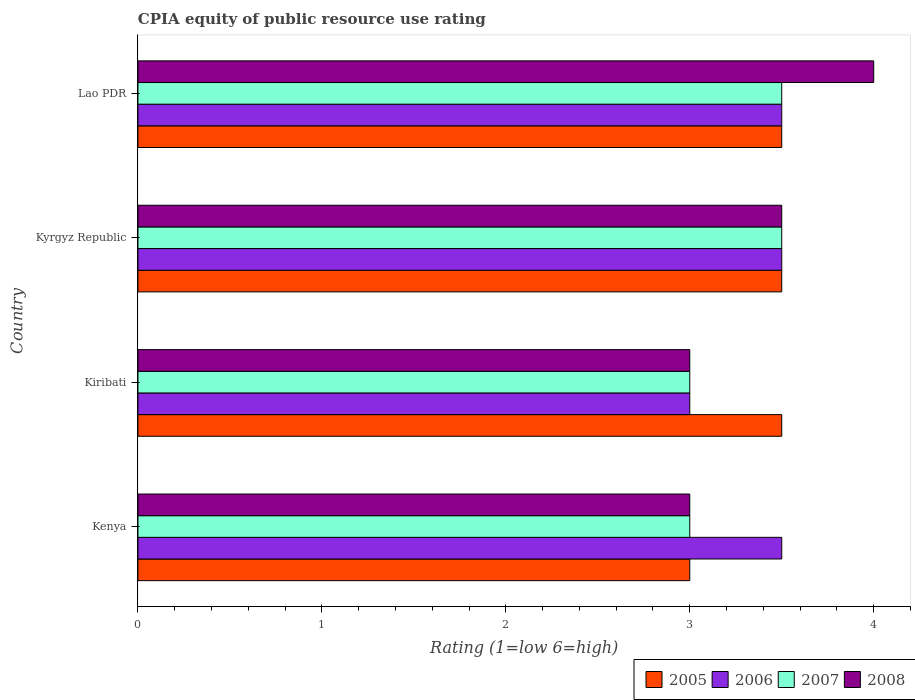Are the number of bars per tick equal to the number of legend labels?
Your answer should be very brief. Yes. Are the number of bars on each tick of the Y-axis equal?
Your answer should be compact. Yes. What is the label of the 2nd group of bars from the top?
Make the answer very short. Kyrgyz Republic. Across all countries, what is the maximum CPIA rating in 2006?
Your answer should be compact. 3.5. In which country was the CPIA rating in 2007 maximum?
Offer a very short reply. Kyrgyz Republic. In which country was the CPIA rating in 2006 minimum?
Offer a very short reply. Kiribati. What is the total CPIA rating in 2005 in the graph?
Keep it short and to the point. 13.5. What is the difference between the CPIA rating in 2005 in Lao PDR and the CPIA rating in 2007 in Kiribati?
Offer a terse response. 0.5. What is the average CPIA rating in 2008 per country?
Your answer should be very brief. 3.38. In how many countries, is the CPIA rating in 2005 greater than 0.8 ?
Offer a very short reply. 4. What is the ratio of the CPIA rating in 2005 in Kenya to that in Kiribati?
Your answer should be compact. 0.86. Is the CPIA rating in 2007 in Kiribati less than that in Lao PDR?
Make the answer very short. Yes. Is the difference between the CPIA rating in 2008 in Kenya and Kiribati greater than the difference between the CPIA rating in 2007 in Kenya and Kiribati?
Make the answer very short. No. What is the difference between the highest and the lowest CPIA rating in 2007?
Keep it short and to the point. 0.5. In how many countries, is the CPIA rating in 2006 greater than the average CPIA rating in 2006 taken over all countries?
Give a very brief answer. 3. What does the 2nd bar from the bottom in Kyrgyz Republic represents?
Your answer should be very brief. 2006. How many bars are there?
Give a very brief answer. 16. How many countries are there in the graph?
Give a very brief answer. 4. What is the difference between two consecutive major ticks on the X-axis?
Ensure brevity in your answer.  1. Are the values on the major ticks of X-axis written in scientific E-notation?
Ensure brevity in your answer.  No. Does the graph contain any zero values?
Ensure brevity in your answer.  No. Does the graph contain grids?
Keep it short and to the point. No. How many legend labels are there?
Provide a succinct answer. 4. What is the title of the graph?
Ensure brevity in your answer.  CPIA equity of public resource use rating. What is the label or title of the X-axis?
Offer a very short reply. Rating (1=low 6=high). What is the label or title of the Y-axis?
Your answer should be very brief. Country. What is the Rating (1=low 6=high) of 2008 in Kenya?
Your answer should be compact. 3. What is the Rating (1=low 6=high) in 2006 in Kyrgyz Republic?
Your response must be concise. 3.5. What is the Rating (1=low 6=high) of 2007 in Kyrgyz Republic?
Keep it short and to the point. 3.5. What is the Rating (1=low 6=high) in 2005 in Lao PDR?
Your answer should be very brief. 3.5. What is the Rating (1=low 6=high) in 2006 in Lao PDR?
Provide a short and direct response. 3.5. What is the Rating (1=low 6=high) in 2007 in Lao PDR?
Keep it short and to the point. 3.5. What is the Rating (1=low 6=high) in 2008 in Lao PDR?
Offer a terse response. 4. Across all countries, what is the maximum Rating (1=low 6=high) of 2005?
Offer a very short reply. 3.5. Across all countries, what is the maximum Rating (1=low 6=high) of 2007?
Your response must be concise. 3.5. Across all countries, what is the minimum Rating (1=low 6=high) in 2005?
Offer a very short reply. 3. Across all countries, what is the minimum Rating (1=low 6=high) in 2008?
Make the answer very short. 3. What is the total Rating (1=low 6=high) in 2006 in the graph?
Give a very brief answer. 13.5. What is the total Rating (1=low 6=high) in 2007 in the graph?
Provide a succinct answer. 13. What is the total Rating (1=low 6=high) in 2008 in the graph?
Your response must be concise. 13.5. What is the difference between the Rating (1=low 6=high) in 2005 in Kenya and that in Kiribati?
Provide a short and direct response. -0.5. What is the difference between the Rating (1=low 6=high) in 2008 in Kenya and that in Kiribati?
Provide a short and direct response. 0. What is the difference between the Rating (1=low 6=high) of 2005 in Kenya and that in Kyrgyz Republic?
Your response must be concise. -0.5. What is the difference between the Rating (1=low 6=high) of 2008 in Kenya and that in Kyrgyz Republic?
Provide a succinct answer. -0.5. What is the difference between the Rating (1=low 6=high) in 2005 in Kenya and that in Lao PDR?
Ensure brevity in your answer.  -0.5. What is the difference between the Rating (1=low 6=high) in 2006 in Kenya and that in Lao PDR?
Ensure brevity in your answer.  0. What is the difference between the Rating (1=low 6=high) of 2007 in Kenya and that in Lao PDR?
Your answer should be very brief. -0.5. What is the difference between the Rating (1=low 6=high) in 2008 in Kenya and that in Lao PDR?
Your response must be concise. -1. What is the difference between the Rating (1=low 6=high) in 2005 in Kiribati and that in Kyrgyz Republic?
Ensure brevity in your answer.  0. What is the difference between the Rating (1=low 6=high) of 2007 in Kiribati and that in Kyrgyz Republic?
Offer a terse response. -0.5. What is the difference between the Rating (1=low 6=high) of 2008 in Kiribati and that in Lao PDR?
Make the answer very short. -1. What is the difference between the Rating (1=low 6=high) in 2005 in Kyrgyz Republic and that in Lao PDR?
Keep it short and to the point. 0. What is the difference between the Rating (1=low 6=high) in 2008 in Kyrgyz Republic and that in Lao PDR?
Your response must be concise. -0.5. What is the difference between the Rating (1=low 6=high) of 2007 in Kenya and the Rating (1=low 6=high) of 2008 in Kiribati?
Your answer should be very brief. 0. What is the difference between the Rating (1=low 6=high) of 2005 in Kenya and the Rating (1=low 6=high) of 2006 in Kyrgyz Republic?
Keep it short and to the point. -0.5. What is the difference between the Rating (1=low 6=high) in 2006 in Kenya and the Rating (1=low 6=high) in 2007 in Kyrgyz Republic?
Offer a very short reply. 0. What is the difference between the Rating (1=low 6=high) in 2006 in Kenya and the Rating (1=low 6=high) in 2008 in Kyrgyz Republic?
Offer a very short reply. 0. What is the difference between the Rating (1=low 6=high) of 2005 in Kenya and the Rating (1=low 6=high) of 2006 in Lao PDR?
Keep it short and to the point. -0.5. What is the difference between the Rating (1=low 6=high) of 2005 in Kenya and the Rating (1=low 6=high) of 2007 in Lao PDR?
Offer a terse response. -0.5. What is the difference between the Rating (1=low 6=high) of 2005 in Kenya and the Rating (1=low 6=high) of 2008 in Lao PDR?
Make the answer very short. -1. What is the difference between the Rating (1=low 6=high) of 2006 in Kenya and the Rating (1=low 6=high) of 2007 in Lao PDR?
Your response must be concise. 0. What is the difference between the Rating (1=low 6=high) in 2006 in Kiribati and the Rating (1=low 6=high) in 2007 in Kyrgyz Republic?
Provide a succinct answer. -0.5. What is the difference between the Rating (1=low 6=high) of 2007 in Kiribati and the Rating (1=low 6=high) of 2008 in Kyrgyz Republic?
Give a very brief answer. -0.5. What is the difference between the Rating (1=low 6=high) in 2005 in Kiribati and the Rating (1=low 6=high) in 2006 in Lao PDR?
Keep it short and to the point. 0. What is the difference between the Rating (1=low 6=high) in 2005 in Kiribati and the Rating (1=low 6=high) in 2008 in Lao PDR?
Provide a succinct answer. -0.5. What is the difference between the Rating (1=low 6=high) in 2006 in Kiribati and the Rating (1=low 6=high) in 2008 in Lao PDR?
Offer a terse response. -1. What is the difference between the Rating (1=low 6=high) of 2007 in Kiribati and the Rating (1=low 6=high) of 2008 in Lao PDR?
Your response must be concise. -1. What is the difference between the Rating (1=low 6=high) of 2005 in Kyrgyz Republic and the Rating (1=low 6=high) of 2007 in Lao PDR?
Your response must be concise. 0. What is the difference between the Rating (1=low 6=high) in 2005 in Kyrgyz Republic and the Rating (1=low 6=high) in 2008 in Lao PDR?
Provide a succinct answer. -0.5. What is the average Rating (1=low 6=high) of 2005 per country?
Your answer should be very brief. 3.38. What is the average Rating (1=low 6=high) in 2006 per country?
Offer a terse response. 3.38. What is the average Rating (1=low 6=high) of 2008 per country?
Your answer should be very brief. 3.38. What is the difference between the Rating (1=low 6=high) of 2005 and Rating (1=low 6=high) of 2007 in Kenya?
Make the answer very short. 0. What is the difference between the Rating (1=low 6=high) of 2006 and Rating (1=low 6=high) of 2007 in Kenya?
Ensure brevity in your answer.  0.5. What is the difference between the Rating (1=low 6=high) of 2007 and Rating (1=low 6=high) of 2008 in Kenya?
Make the answer very short. 0. What is the difference between the Rating (1=low 6=high) of 2005 and Rating (1=low 6=high) of 2006 in Kiribati?
Your answer should be compact. 0.5. What is the difference between the Rating (1=low 6=high) in 2005 and Rating (1=low 6=high) in 2008 in Kiribati?
Offer a terse response. 0.5. What is the difference between the Rating (1=low 6=high) in 2006 and Rating (1=low 6=high) in 2008 in Kiribati?
Ensure brevity in your answer.  0. What is the difference between the Rating (1=low 6=high) in 2007 and Rating (1=low 6=high) in 2008 in Kiribati?
Give a very brief answer. 0. What is the difference between the Rating (1=low 6=high) in 2005 and Rating (1=low 6=high) in 2006 in Kyrgyz Republic?
Provide a short and direct response. 0. What is the difference between the Rating (1=low 6=high) of 2006 and Rating (1=low 6=high) of 2008 in Kyrgyz Republic?
Offer a very short reply. 0. What is the difference between the Rating (1=low 6=high) of 2005 and Rating (1=low 6=high) of 2006 in Lao PDR?
Make the answer very short. 0. What is the difference between the Rating (1=low 6=high) in 2005 and Rating (1=low 6=high) in 2008 in Lao PDR?
Provide a succinct answer. -0.5. What is the difference between the Rating (1=low 6=high) of 2006 and Rating (1=low 6=high) of 2008 in Lao PDR?
Your answer should be compact. -0.5. What is the ratio of the Rating (1=low 6=high) of 2008 in Kenya to that in Kiribati?
Make the answer very short. 1. What is the ratio of the Rating (1=low 6=high) in 2006 in Kenya to that in Kyrgyz Republic?
Ensure brevity in your answer.  1. What is the ratio of the Rating (1=low 6=high) of 2007 in Kenya to that in Kyrgyz Republic?
Offer a terse response. 0.86. What is the ratio of the Rating (1=low 6=high) in 2005 in Kenya to that in Lao PDR?
Offer a very short reply. 0.86. What is the ratio of the Rating (1=low 6=high) of 2008 in Kenya to that in Lao PDR?
Provide a succinct answer. 0.75. What is the ratio of the Rating (1=low 6=high) of 2005 in Kiribati to that in Lao PDR?
Ensure brevity in your answer.  1. What is the ratio of the Rating (1=low 6=high) of 2007 in Kiribati to that in Lao PDR?
Offer a very short reply. 0.86. What is the ratio of the Rating (1=low 6=high) of 2005 in Kyrgyz Republic to that in Lao PDR?
Provide a succinct answer. 1. What is the ratio of the Rating (1=low 6=high) in 2007 in Kyrgyz Republic to that in Lao PDR?
Give a very brief answer. 1. What is the ratio of the Rating (1=low 6=high) of 2008 in Kyrgyz Republic to that in Lao PDR?
Offer a terse response. 0.88. What is the difference between the highest and the lowest Rating (1=low 6=high) in 2007?
Ensure brevity in your answer.  0.5. 